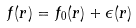Convert formula to latex. <formula><loc_0><loc_0><loc_500><loc_500>f ( r ) = f _ { 0 } ( r ) + \epsilon ( r )</formula> 